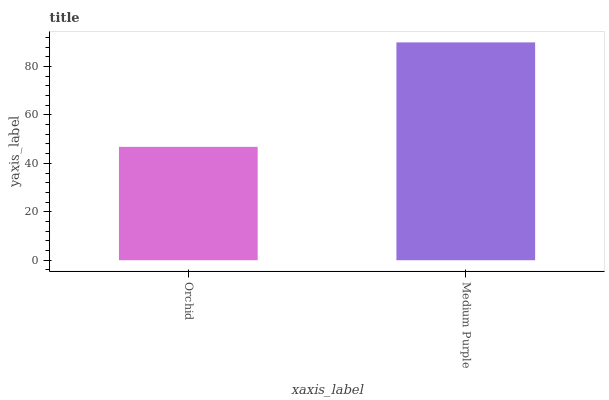Is Medium Purple the minimum?
Answer yes or no. No. Is Medium Purple greater than Orchid?
Answer yes or no. Yes. Is Orchid less than Medium Purple?
Answer yes or no. Yes. Is Orchid greater than Medium Purple?
Answer yes or no. No. Is Medium Purple less than Orchid?
Answer yes or no. No. Is Medium Purple the high median?
Answer yes or no. Yes. Is Orchid the low median?
Answer yes or no. Yes. Is Orchid the high median?
Answer yes or no. No. Is Medium Purple the low median?
Answer yes or no. No. 